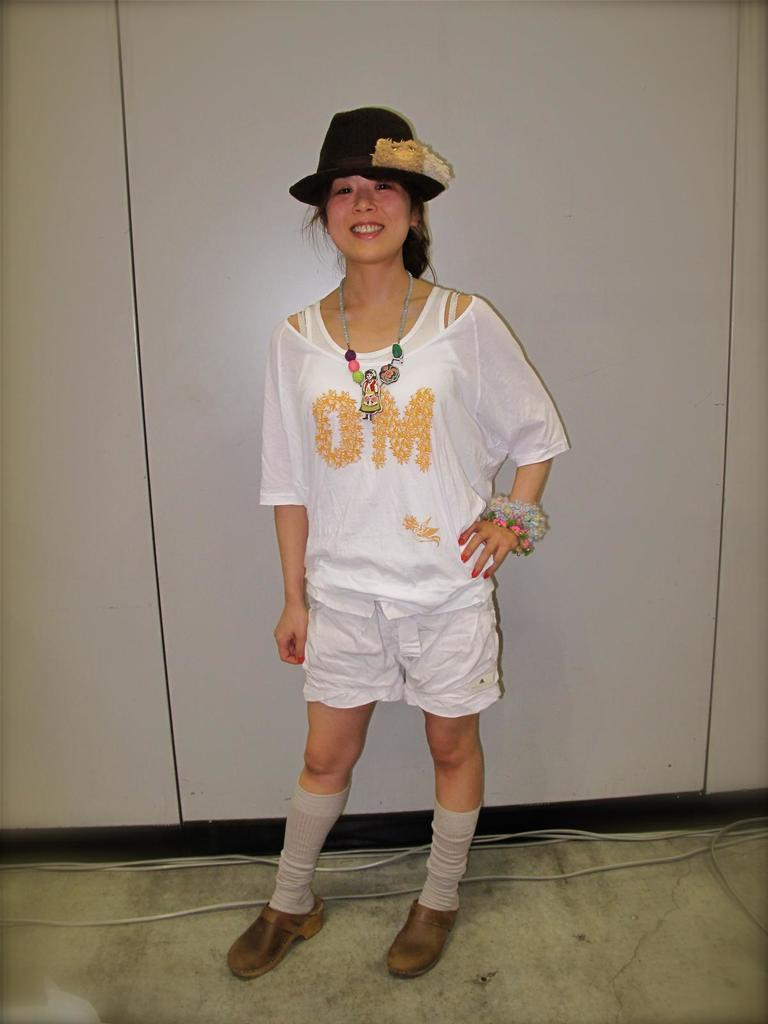Who is present in the image? There is a woman in the image. What is the woman wearing on her head? The woman is wearing a hat. What is the woman's facial expression in the image? The woman is smiling. What is the woman standing on in the image? The woman is standing on the floor. What can be seen in the background of the image? There is a wall and cables in the background of the image. What type of mass is the woman holding in her hands in the image? There is no mass visible in the woman's hands in the image. Can you point out the map in the image? There is no map present in the image. 